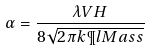Convert formula to latex. <formula><loc_0><loc_0><loc_500><loc_500>\alpha = \frac { \lambda V H } { 8 \sqrt { 2 \pi k \P l M a s s } }</formula> 